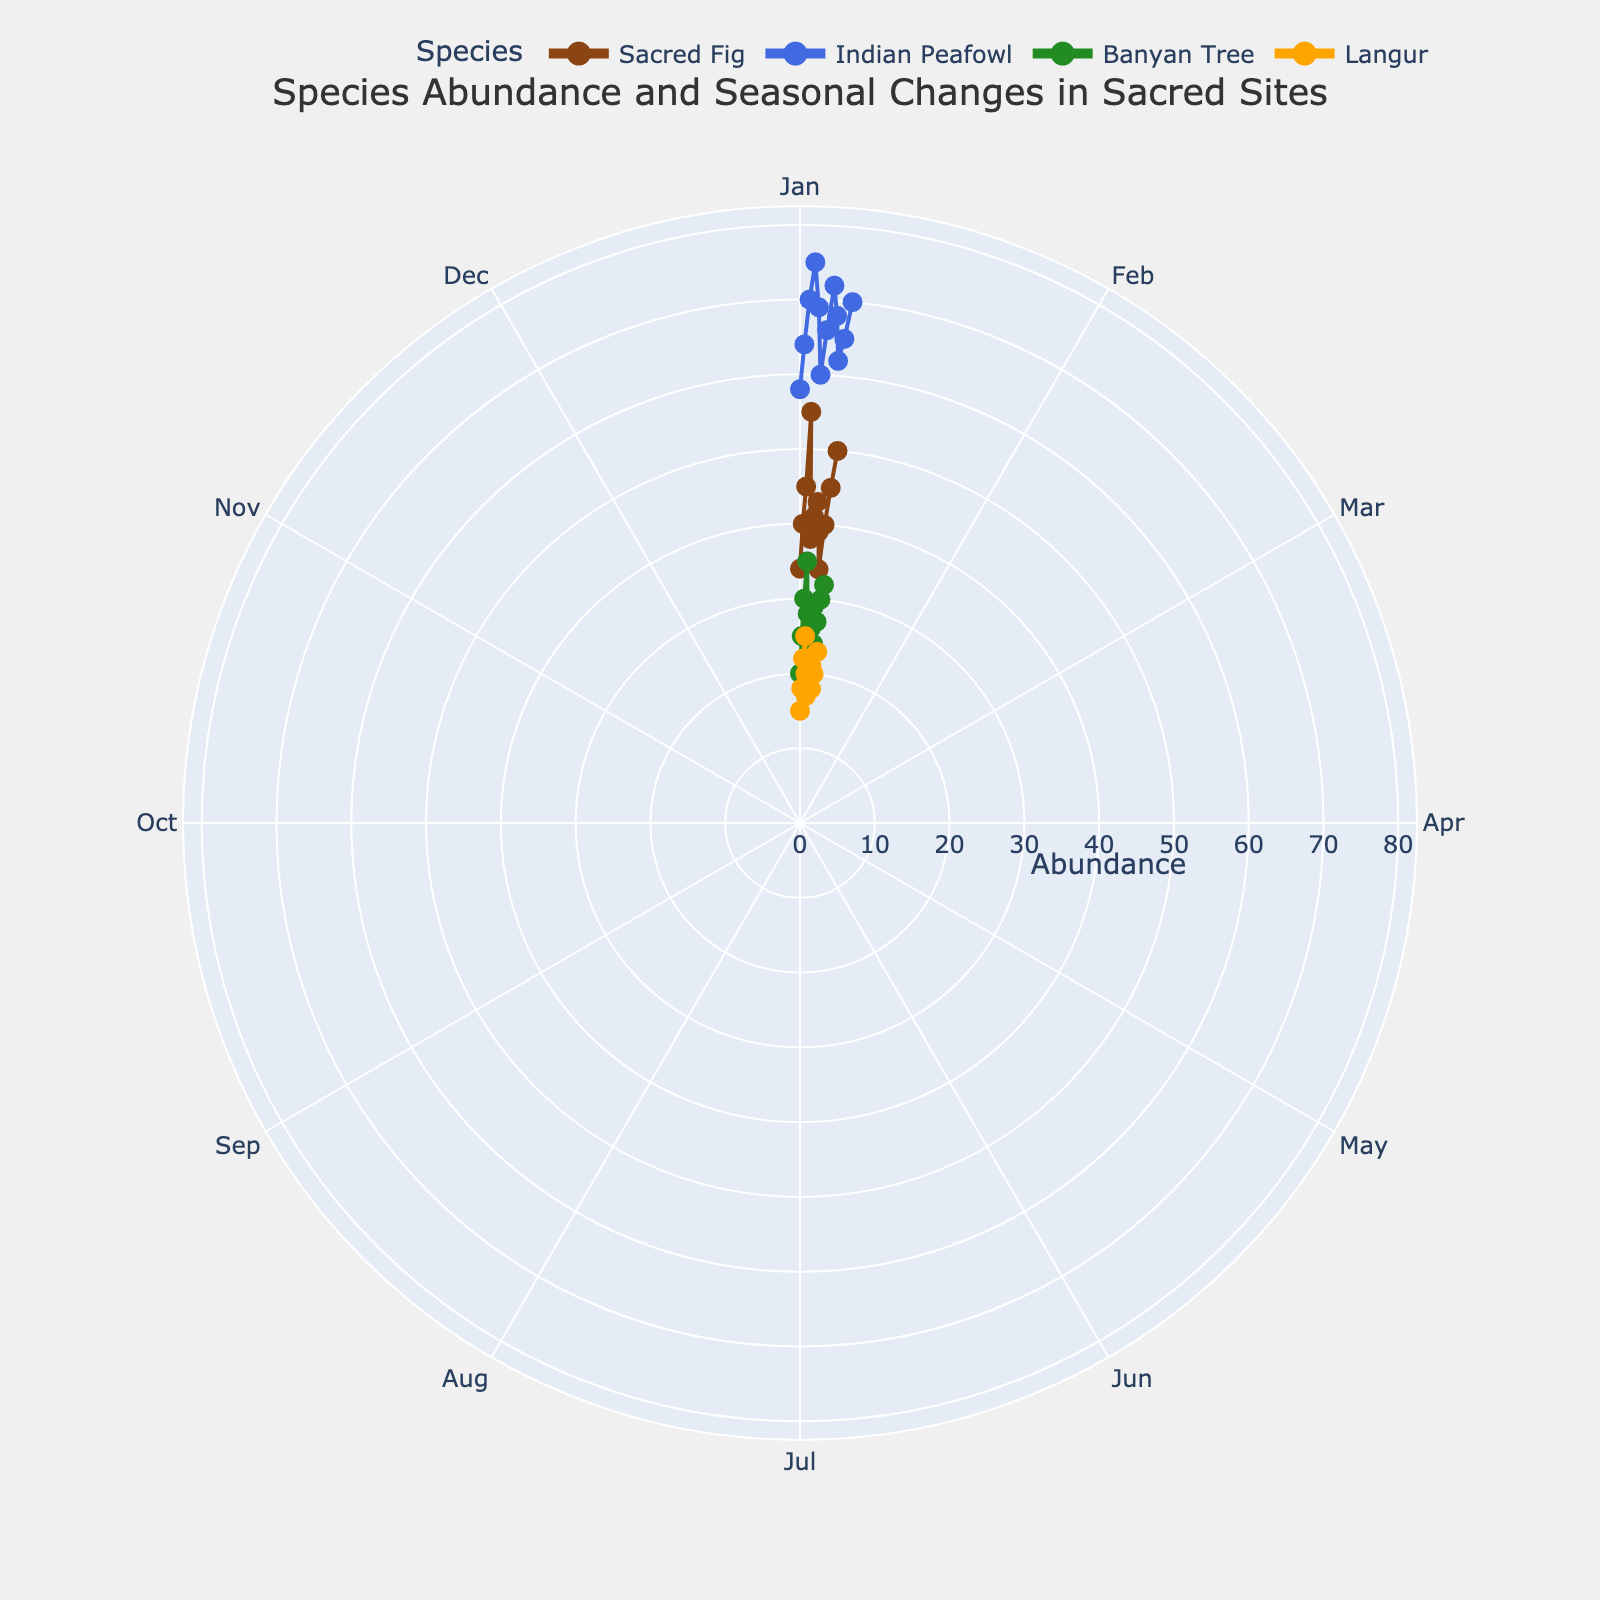What is the title of the figure? The title of the figure is centered at the top of the chart and is clearly mentioned.
Answer: Species Abundance and Seasonal Changes in Sacred Sites How does the abundance of Sacred Fig change throughout the year? By following the line and markers for Sacred Fig (in brown color), the abundance starts at 34 in January, rises to a peak of 55 in April, falls to 34 again in September, and ends at 50 in December.
Answer: Peaks in April, decreases, and rises again in December Which species has the highest abundance in June? By looking at the data points on the radial axis for June across all species, the Indian Peafowl (in blue) has the highest abundance at 60 in June.
Answer: Indian Peafowl Comparing the abundance of the Banyan Tree and Langur in October, which one is higher? By locating both species' data points for October, the Banyan Tree, represented by the green color, has an abundance of 27, while the Langur, represented by the orange color, has an abundance of 18. Hence, the Banyan Tree's abundance is higher.
Answer: Banyan Tree What is the average abundance of the Indian Peafowl across the year? To calculate the average, sum the monthly abundances of the Indian Peafowl and divide by 12. The abundances are 58, 64, 70, 75, 69, 60, 66, 72, 68, 62, 65, 70. Sum: 799. Average: 799 / 12.
Answer: 66.58 Which month shows the lowest abundance for Langur? By examining the data points for Langur (in orange color) throughout the year, the lowest abundance is 15, occurring in January.
Answer: January How many species have their highest abundance in a month other than April? By inspecting the peak abundances for each species and the month in which they occur, the Sacred Fig peaks in April, Indian Peafowl peaks in April, Banyan Tree does not (peaks in April), Langur peaks in April. Thus, no species peaks in a month other than April.
Answer: 0 Is there any species that shows a consistent increase or decrease in abundance throughout the year? By inspecting the trend lines for each species, none of the species show a strictly consistent increase or decrease over all 12 months. All species have some fluctuations.
Answer: No What is the difference in the highest and lowest abundances for Banyan Tree across the year? The highest abundance for the Banyan Tree is 35 in April and the lowest is 20 in January. Subtracting 20 from 35 gives the difference.
Answer: 15 